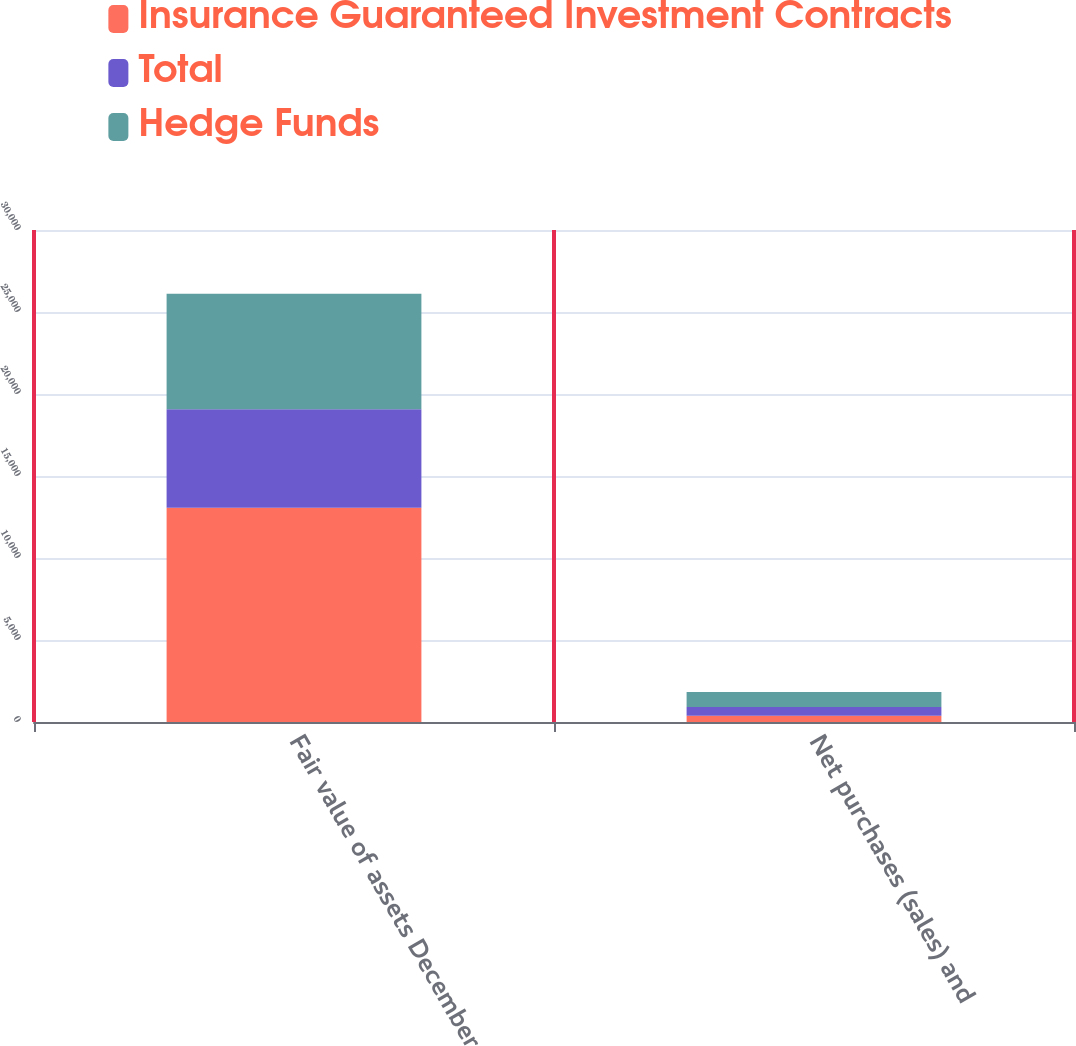<chart> <loc_0><loc_0><loc_500><loc_500><stacked_bar_chart><ecel><fcel>Fair value of assets December<fcel>Net purchases (sales) and<nl><fcel>Insurance Guaranteed Investment Contracts<fcel>13057<fcel>376<nl><fcel>Total<fcel>6018<fcel>535<nl><fcel>Hedge Funds<fcel>7039<fcel>911<nl></chart> 